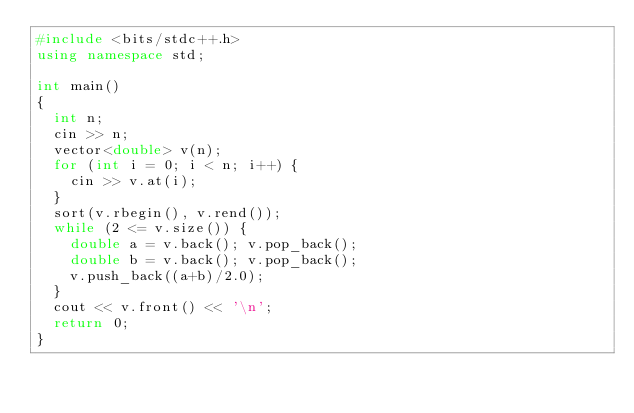Convert code to text. <code><loc_0><loc_0><loc_500><loc_500><_C++_>#include <bits/stdc++.h>
using namespace std;

int main()
{
  int n;
  cin >> n;
  vector<double> v(n);
  for (int i = 0; i < n; i++) {
    cin >> v.at(i);
  }
  sort(v.rbegin(), v.rend());
  while (2 <= v.size()) {
    double a = v.back(); v.pop_back();
    double b = v.back(); v.pop_back();
    v.push_back((a+b)/2.0);
  }
  cout << v.front() << '\n';
  return 0;
}
</code> 